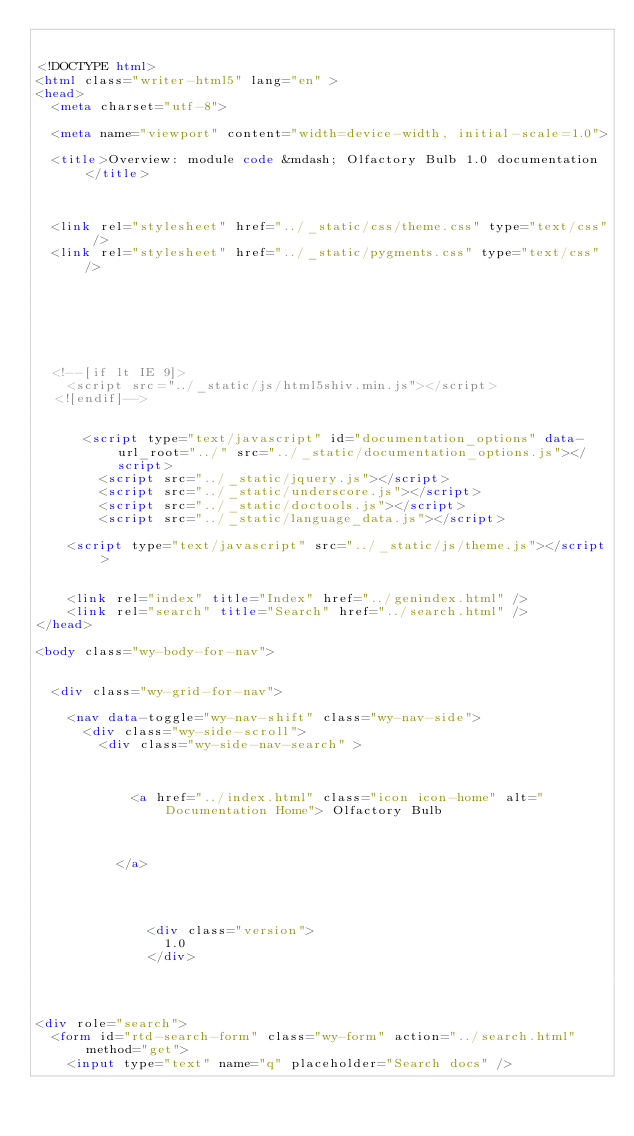Convert code to text. <code><loc_0><loc_0><loc_500><loc_500><_HTML_>

<!DOCTYPE html>
<html class="writer-html5" lang="en" >
<head>
  <meta charset="utf-8">
  
  <meta name="viewport" content="width=device-width, initial-scale=1.0">
  
  <title>Overview: module code &mdash; Olfactory Bulb 1.0 documentation</title>
  

  
  <link rel="stylesheet" href="../_static/css/theme.css" type="text/css" />
  <link rel="stylesheet" href="../_static/pygments.css" type="text/css" />

  
  
  
  

  
  <!--[if lt IE 9]>
    <script src="../_static/js/html5shiv.min.js"></script>
  <![endif]-->
  
    
      <script type="text/javascript" id="documentation_options" data-url_root="../" src="../_static/documentation_options.js"></script>
        <script src="../_static/jquery.js"></script>
        <script src="../_static/underscore.js"></script>
        <script src="../_static/doctools.js"></script>
        <script src="../_static/language_data.js"></script>
    
    <script type="text/javascript" src="../_static/js/theme.js"></script>

    
    <link rel="index" title="Index" href="../genindex.html" />
    <link rel="search" title="Search" href="../search.html" /> 
</head>

<body class="wy-body-for-nav">

   
  <div class="wy-grid-for-nav">
    
    <nav data-toggle="wy-nav-shift" class="wy-nav-side">
      <div class="wy-side-scroll">
        <div class="wy-side-nav-search" >
          

          
            <a href="../index.html" class="icon icon-home" alt="Documentation Home"> Olfactory Bulb
          

          
          </a>

          
            
            
              <div class="version">
                1.0
              </div>
            
          

          
<div role="search">
  <form id="rtd-search-form" class="wy-form" action="../search.html" method="get">
    <input type="text" name="q" placeholder="Search docs" /></code> 